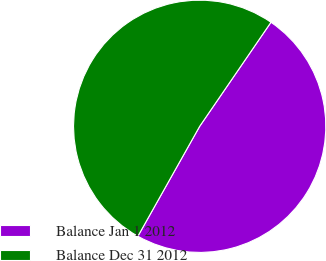Convert chart. <chart><loc_0><loc_0><loc_500><loc_500><pie_chart><fcel>Balance Jan 1 2012<fcel>Balance Dec 31 2012<nl><fcel>48.59%<fcel>51.41%<nl></chart> 